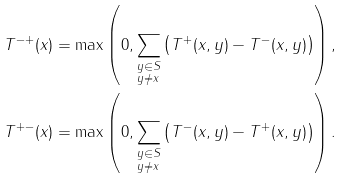Convert formula to latex. <formula><loc_0><loc_0><loc_500><loc_500>T ^ { - + } ( x ) & = \max \left ( 0 , \sum _ { \substack { y \in S \\ y \neq x } } \left ( T ^ { + } ( x , y ) - T ^ { - } ( x , y ) \right ) \right ) , \\ T ^ { + - } ( x ) & = \max \left ( 0 , \sum _ { \substack { y \in S \\ y \neq x } } \left ( T ^ { - } ( x , y ) - T ^ { + } ( x , y ) \right ) \right ) .</formula> 